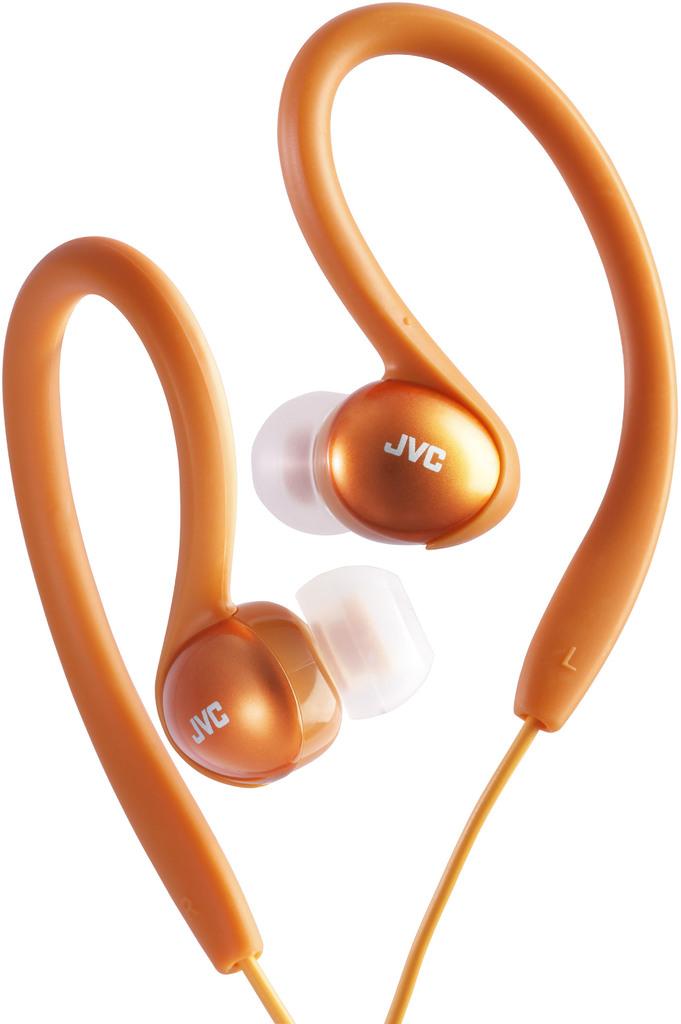What brand are these?
Provide a succinct answer. Jvc. 